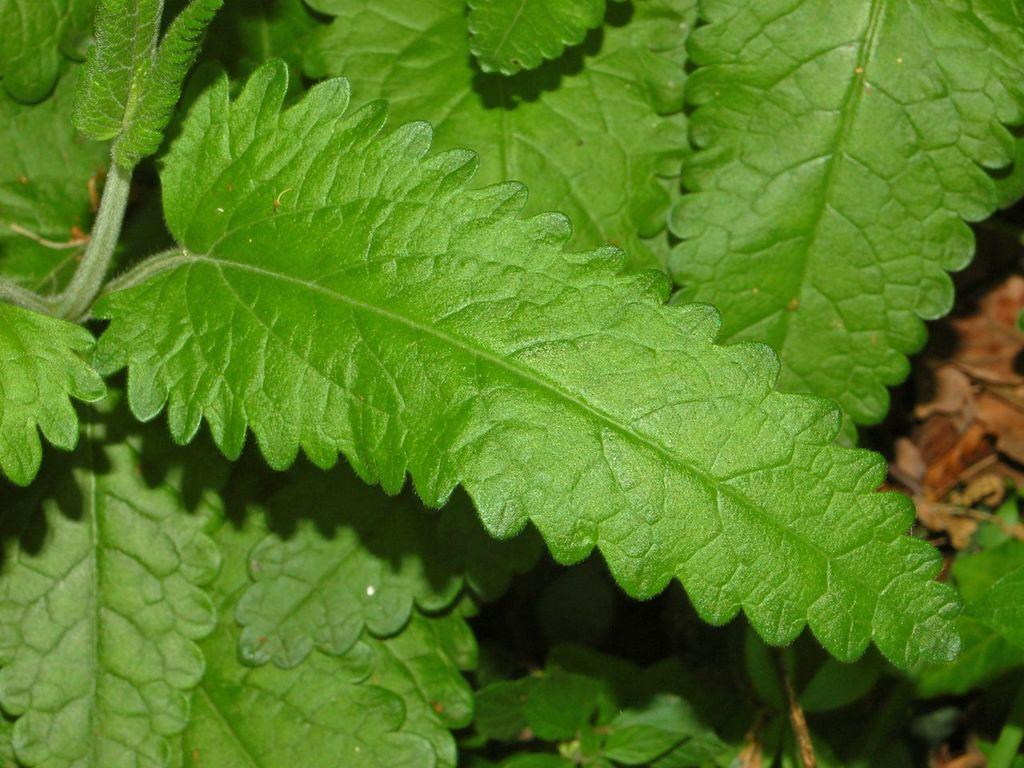What is in the foreground of the image? There are leaves and a stem in the foreground of the image. What can be seen in the background of the image? There are plants in the background of the image. Can you describe the right side of the background in the image? There are dry leaves on the right side of the background, but they are blurred. How many eyes can be seen on the plants in the image? Plants do not have eyes, so there are no eyes visible on the plants in the image. 